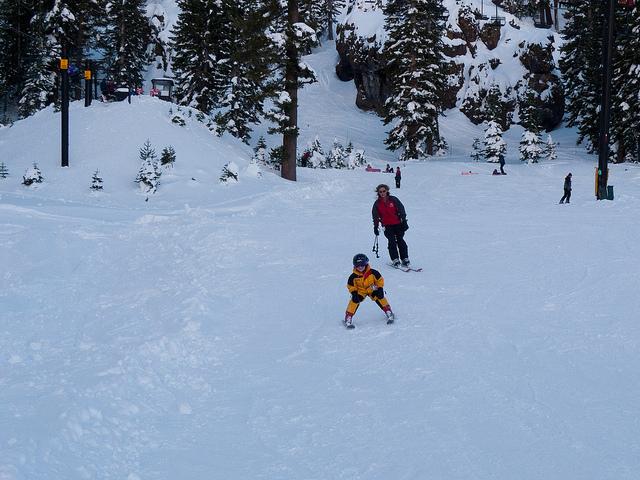Is the person in yellow a professional skier?
Short answer required. No. Is the person good at skiing?
Quick response, please. Yes. Is skiing a competitive sport?
Give a very brief answer. Yes. If this is a race, which skier is winning?
Concise answer only. Yellow. What is the color of the snow?
Keep it brief. White. Are they both holding skiing sticks?
Be succinct. No. 